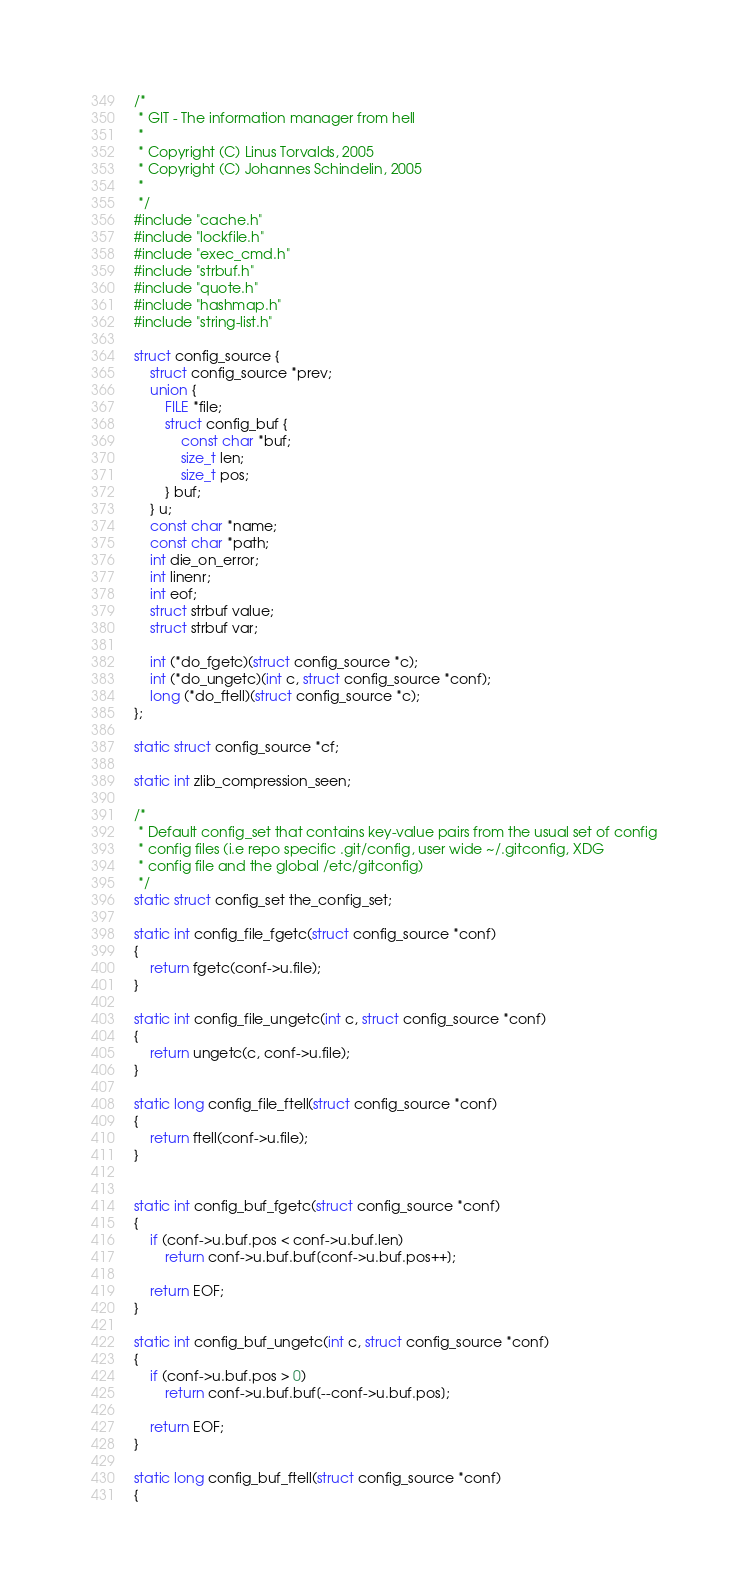<code> <loc_0><loc_0><loc_500><loc_500><_C_>/*
 * GIT - The information manager from hell
 *
 * Copyright (C) Linus Torvalds, 2005
 * Copyright (C) Johannes Schindelin, 2005
 *
 */
#include "cache.h"
#include "lockfile.h"
#include "exec_cmd.h"
#include "strbuf.h"
#include "quote.h"
#include "hashmap.h"
#include "string-list.h"

struct config_source {
	struct config_source *prev;
	union {
		FILE *file;
		struct config_buf {
			const char *buf;
			size_t len;
			size_t pos;
		} buf;
	} u;
	const char *name;
	const char *path;
	int die_on_error;
	int linenr;
	int eof;
	struct strbuf value;
	struct strbuf var;

	int (*do_fgetc)(struct config_source *c);
	int (*do_ungetc)(int c, struct config_source *conf);
	long (*do_ftell)(struct config_source *c);
};

static struct config_source *cf;

static int zlib_compression_seen;

/*
 * Default config_set that contains key-value pairs from the usual set of config
 * config files (i.e repo specific .git/config, user wide ~/.gitconfig, XDG
 * config file and the global /etc/gitconfig)
 */
static struct config_set the_config_set;

static int config_file_fgetc(struct config_source *conf)
{
	return fgetc(conf->u.file);
}

static int config_file_ungetc(int c, struct config_source *conf)
{
	return ungetc(c, conf->u.file);
}

static long config_file_ftell(struct config_source *conf)
{
	return ftell(conf->u.file);
}


static int config_buf_fgetc(struct config_source *conf)
{
	if (conf->u.buf.pos < conf->u.buf.len)
		return conf->u.buf.buf[conf->u.buf.pos++];

	return EOF;
}

static int config_buf_ungetc(int c, struct config_source *conf)
{
	if (conf->u.buf.pos > 0)
		return conf->u.buf.buf[--conf->u.buf.pos];

	return EOF;
}

static long config_buf_ftell(struct config_source *conf)
{</code> 